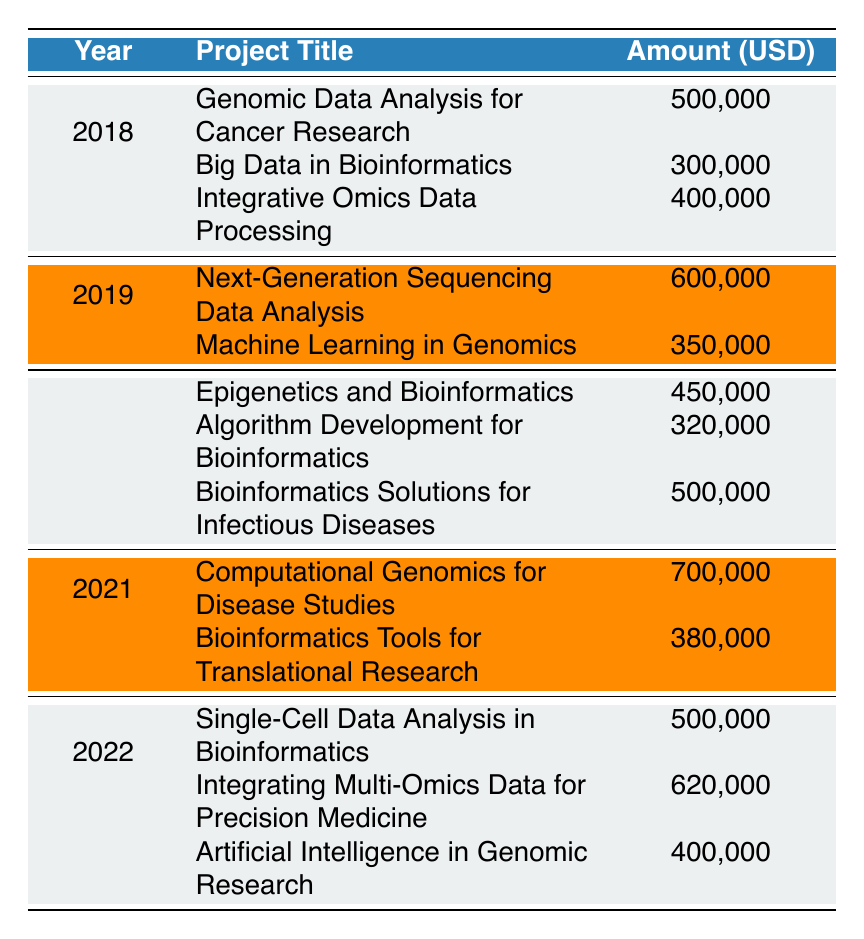What was the total grant funding received by the lab in 2021? The table lists two grants for the year 2021: Computational Genomics for Disease Studies amounting to 700,000 and Bioinformatics Tools for Translational Research amounting to 380,000. Adding these amounts gives 700,000 + 380,000 = 1,080,000.
Answer: 1,080,000 Which funding agency provided the most funding in 2019? In 2019, there were two grants: Next-Generation Sequencing Data Analysis from NIH for 600,000 and Machine Learning in Genomics from Wellcome Trust for 350,000. The higher funding amount is 600,000 from NIH.
Answer: NIH How many projects were funded in total from 2018 to 2022? By counting each project listed in the years 2018 to 2022, there are 3 projects in 2018, 2 in 2019, 3 in 2020, 2 in 2021, and 3 in 2022. Thus, the total is 3 + 2 + 3 + 2 + 3 = 13 projects.
Answer: 13 Was the funding from the National Science Foundation (NSF) consistent each year? The NSF provided funds in 2018, 2020, and 2022 with amounts of 300,000, 320,000, and 400,000 respectively. The amounts vary each year; therefore, the funding was not consistent.
Answer: No What was the average amount of funding received per year from 2020 to 2022? The total funding for these years can be calculated: 450,000 (2020) + 500,000 (2020) + 700,000 (2021) + 500,000 (2022) + 620,000 (2022) + 400,000 (2022) = 3,170,000. There are 3 years in total, hence the average is 3,170,000 / 8 = 396,250.
Answer: 396,250 Which project title received the highest amount in 2020? In 2020, the projects were: Epigenetics and Bioinformatics for 450,000, Algorithm Development for Bioinformatics for 320,000, and Bioinformatics Solutions for Infectious Diseases for 500,000. The highest amount is from Bioinformatics Solutions for Infectious Diseases at 500,000.
Answer: Bioinformatics Solutions for Infectious Diseases What is the total grant funding received from the European Research Council (ERC) from 2018 to 2022? The ERC funded two projects: Integrative Omics Data Processing in 2018 for 400,000 and Single-Cell Data Analysis in Bioinformatics in 2022 for 500,000. Adding these amounts gives 400,000 + 500,000 = 900,000.
Answer: 900,000 Did the National Institutes of Health (NIH) fund a project in every year from 2018 to 2022? Reviewing the table, NIH funded projects in 2018, 2019, 2021, and 2022. However, they did not fund a project in 2020, therefore the statement is false.
Answer: No 